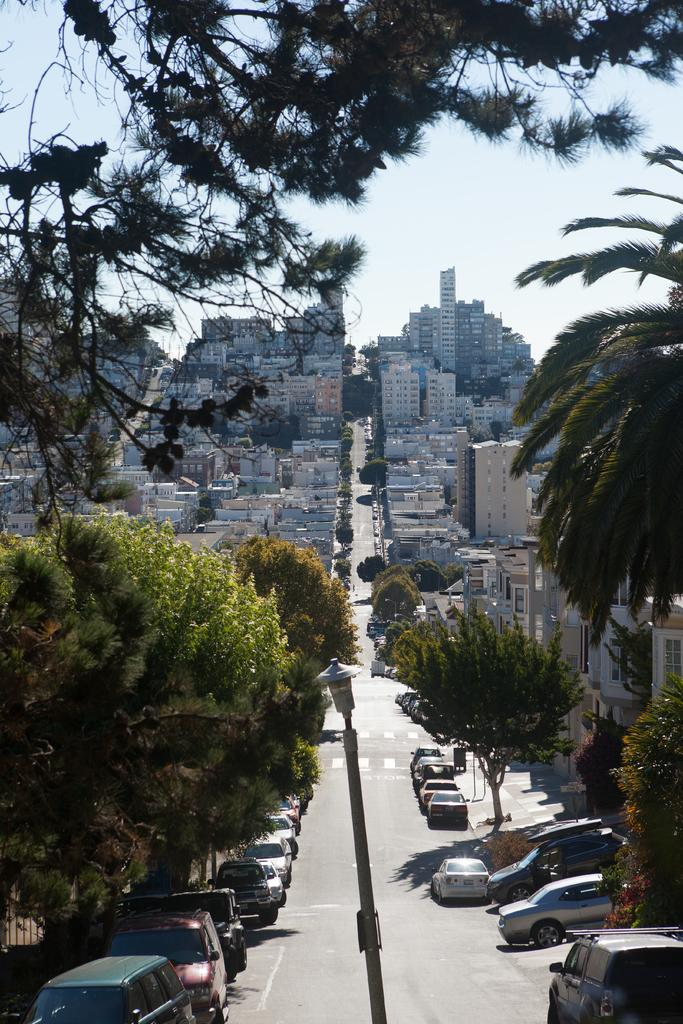What type of natural vegetation is present in the image? There is a group of trees in the image. What type of man-made structures can be seen in the image? There are buildings in the image. What type of transportation is visible in the image? There are vehicles in the image. What object is located in the foreground of the image? There is a pole in the foreground of the image. What is visible at the top of the image? The sky is visible at the top of the image. What type of decision can be seen being made by the jellyfish in the image? There are no jellyfish present in the image, so no such decision can be observed. 